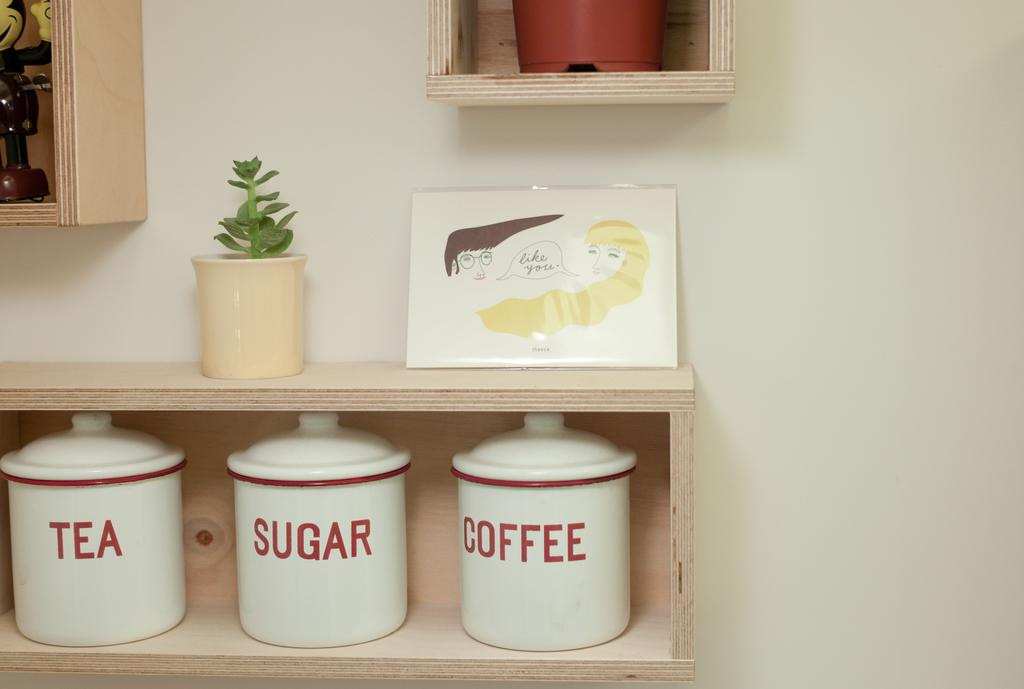Provide a one-sentence caption for the provided image. On a plain beech box shelf stand three white canisters with red writing, which contain tea, coffee and sugar. 